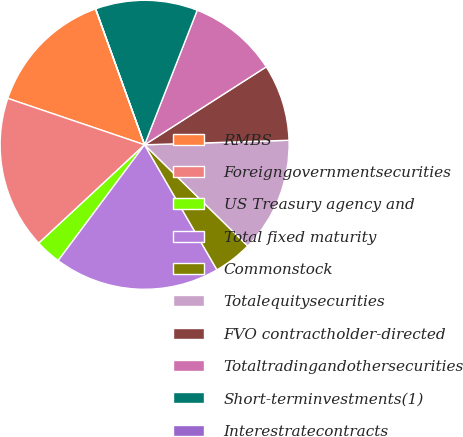Convert chart. <chart><loc_0><loc_0><loc_500><loc_500><pie_chart><fcel>RMBS<fcel>Foreigngovernmentsecurities<fcel>US Treasury agency and<fcel>Total fixed maturity<fcel>Commonstock<fcel>Totalequitysecurities<fcel>FVO contractholder-directed<fcel>Totaltradingandothersecurities<fcel>Short-terminvestments(1)<fcel>Interestratecontracts<nl><fcel>14.28%<fcel>17.13%<fcel>2.87%<fcel>18.56%<fcel>4.3%<fcel>12.85%<fcel>8.57%<fcel>10.0%<fcel>11.43%<fcel>0.02%<nl></chart> 